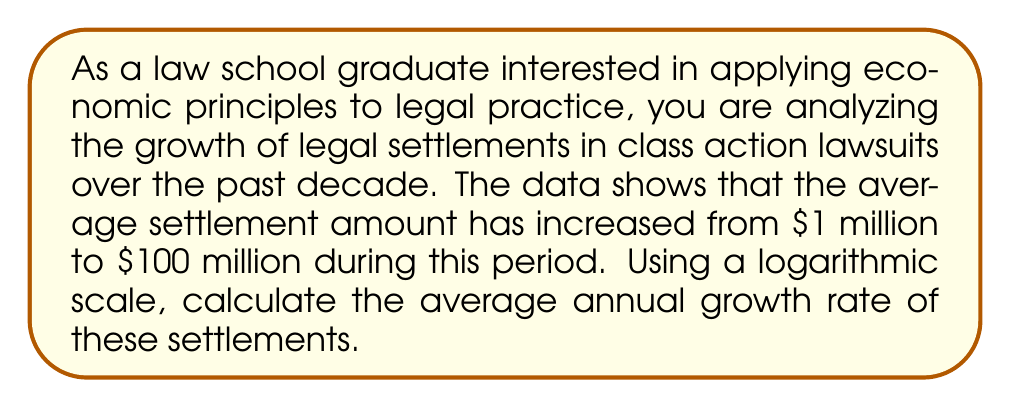What is the answer to this math problem? To solve this problem, we'll use the properties of logarithms and exponential growth. Let's break it down step-by-step:

1) The general formula for exponential growth is:

   $$A = P(1 + r)^t$$

   Where:
   $A$ is the final amount
   $P$ is the initial amount
   $r$ is the annual growth rate
   $t$ is the time in years

2) In this case:
   $A = 100$ million
   $P = 1$ million
   $t = 10$ years

3) Substituting these values:

   $$100 = 1(1 + r)^{10}$$

4) To solve for $r$, we can use logarithms. First, divide both sides by 1:

   $$100 = (1 + r)^{10}$$

5) Now, take the logarithm of both sides. We'll use the natural log (ln) for simplicity:

   $$\ln(100) = \ln((1 + r)^{10})$$

6) Using the logarithm property $\ln(a^b) = b\ln(a)$:

   $$\ln(100) = 10\ln(1 + r)$$

7) Divide both sides by 10:

   $$\frac{\ln(100)}{10} = \ln(1 + r)$$

8) Now, take $e$ to the power of both sides to remove the ln:

   $$e^{\frac{\ln(100)}{10}} = e^{\ln(1 + r)} = 1 + r$$

9) Subtract 1 from both sides:

   $$e^{\frac{\ln(100)}{10}} - 1 = r$$

10) Calculate:
    $\ln(100) \approx 4.60517$
    $\frac{4.60517}{10} \approx 0.460517$
    $e^{0.460517} \approx 1.58489$
    $1.58489 - 1 \approx 0.58489$

Therefore, the average annual growth rate is approximately 0.58489, or about 58.49%.
Answer: The average annual growth rate of legal settlements is approximately 58.49%. 